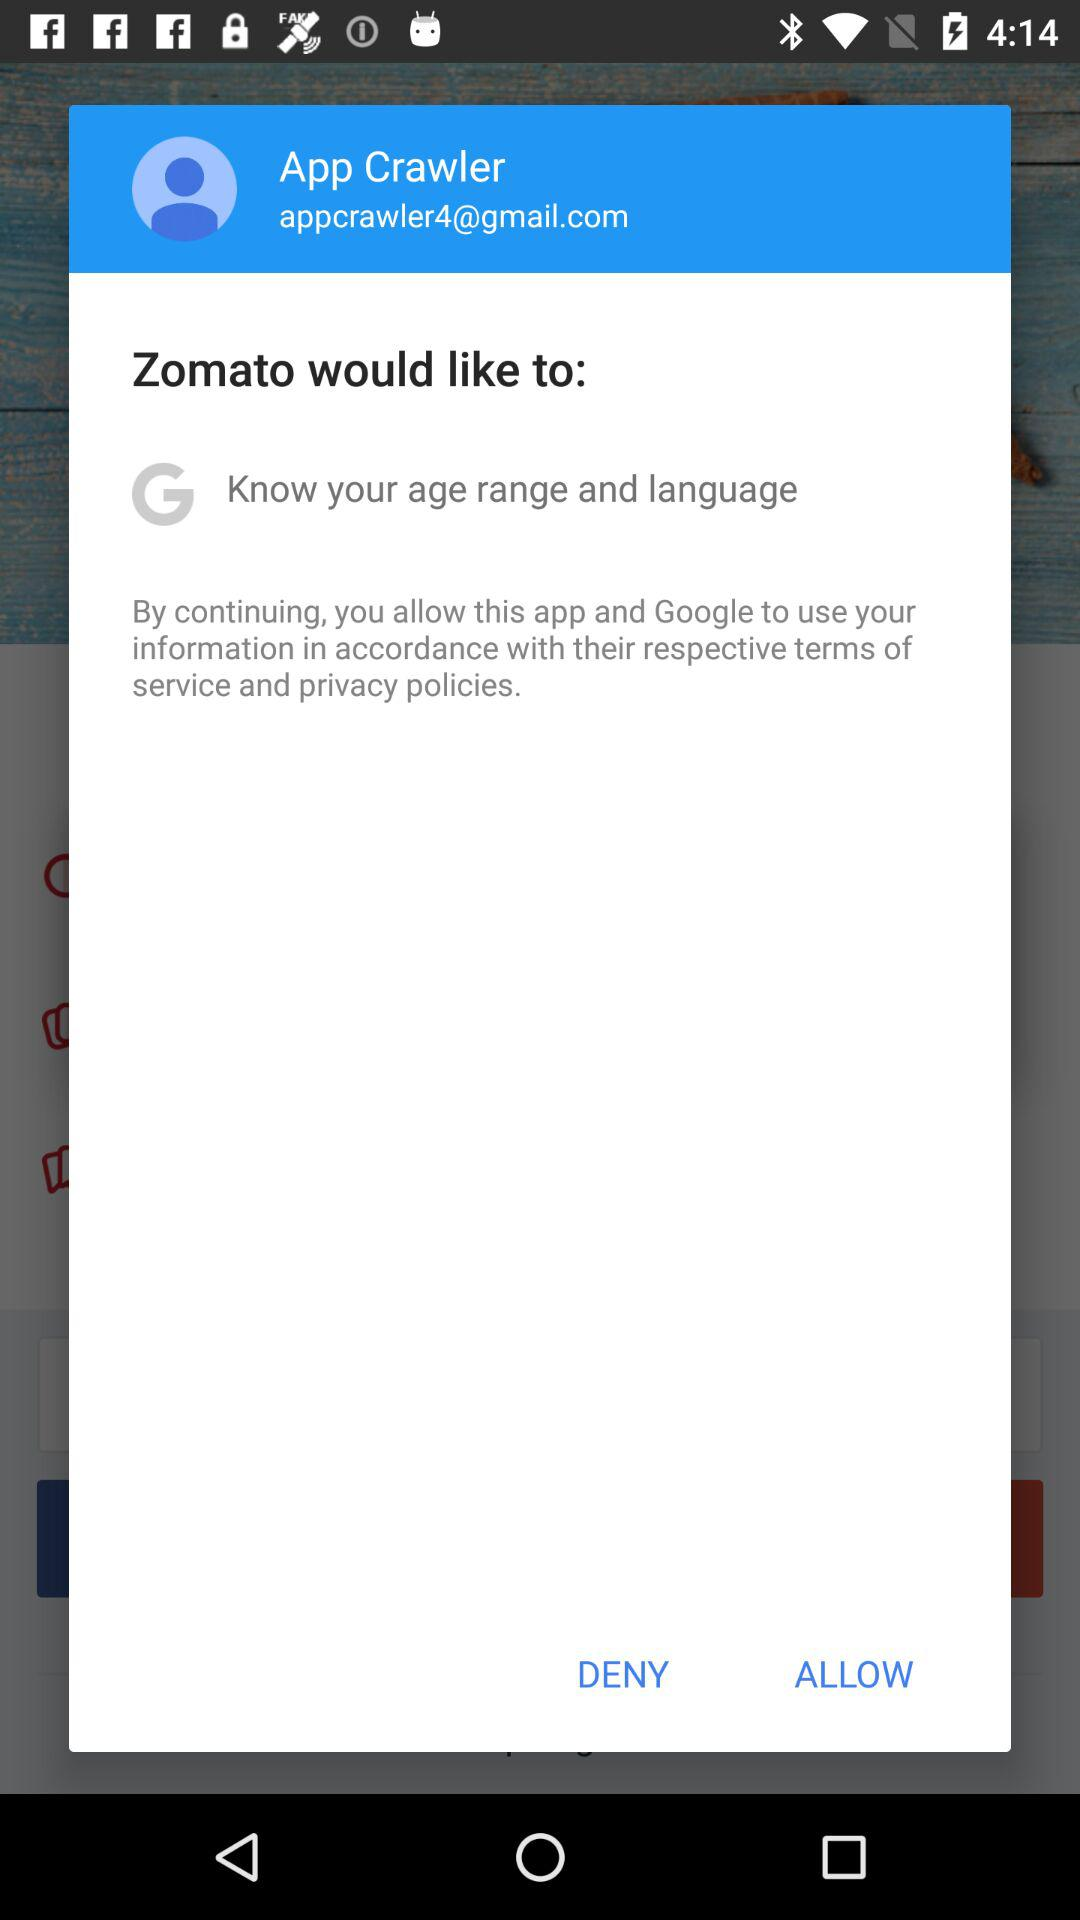What is the email ID of the user? The email ID is appcrawler4@gmail.com. 